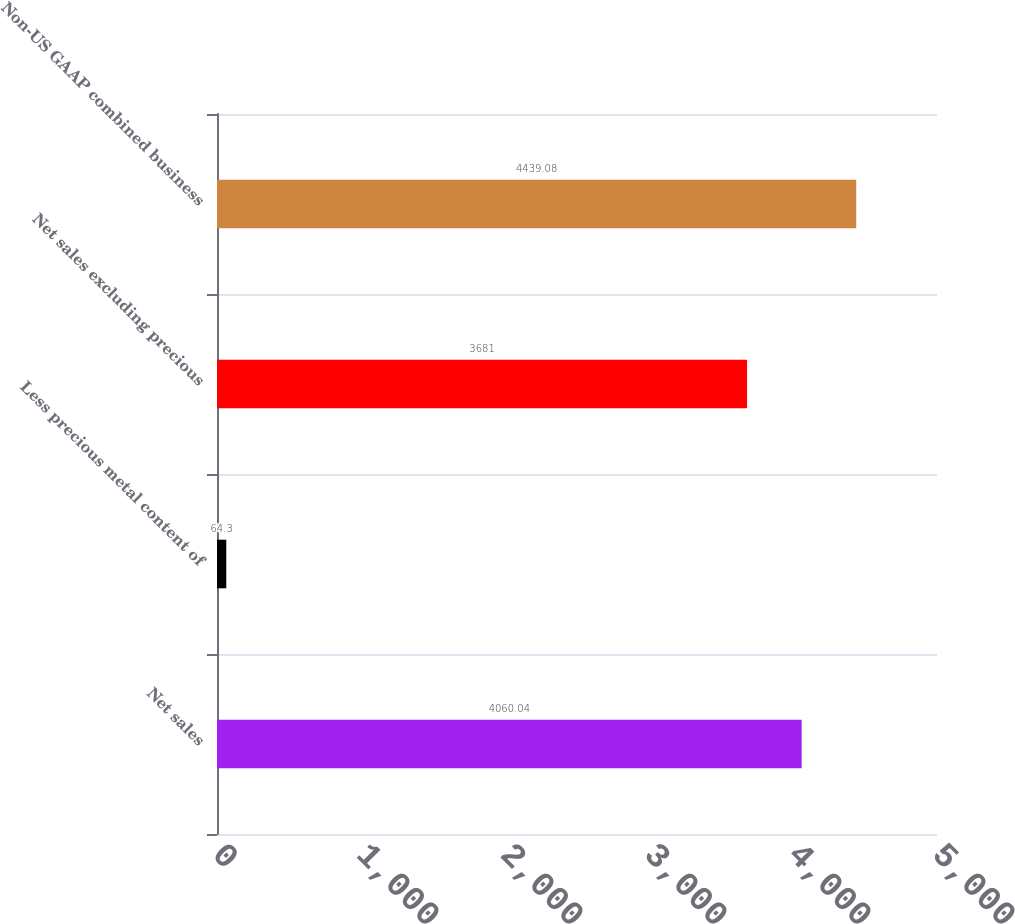Convert chart to OTSL. <chart><loc_0><loc_0><loc_500><loc_500><bar_chart><fcel>Net sales<fcel>Less precious metal content of<fcel>Net sales excluding precious<fcel>Non-US GAAP combined business<nl><fcel>4060.04<fcel>64.3<fcel>3681<fcel>4439.08<nl></chart> 